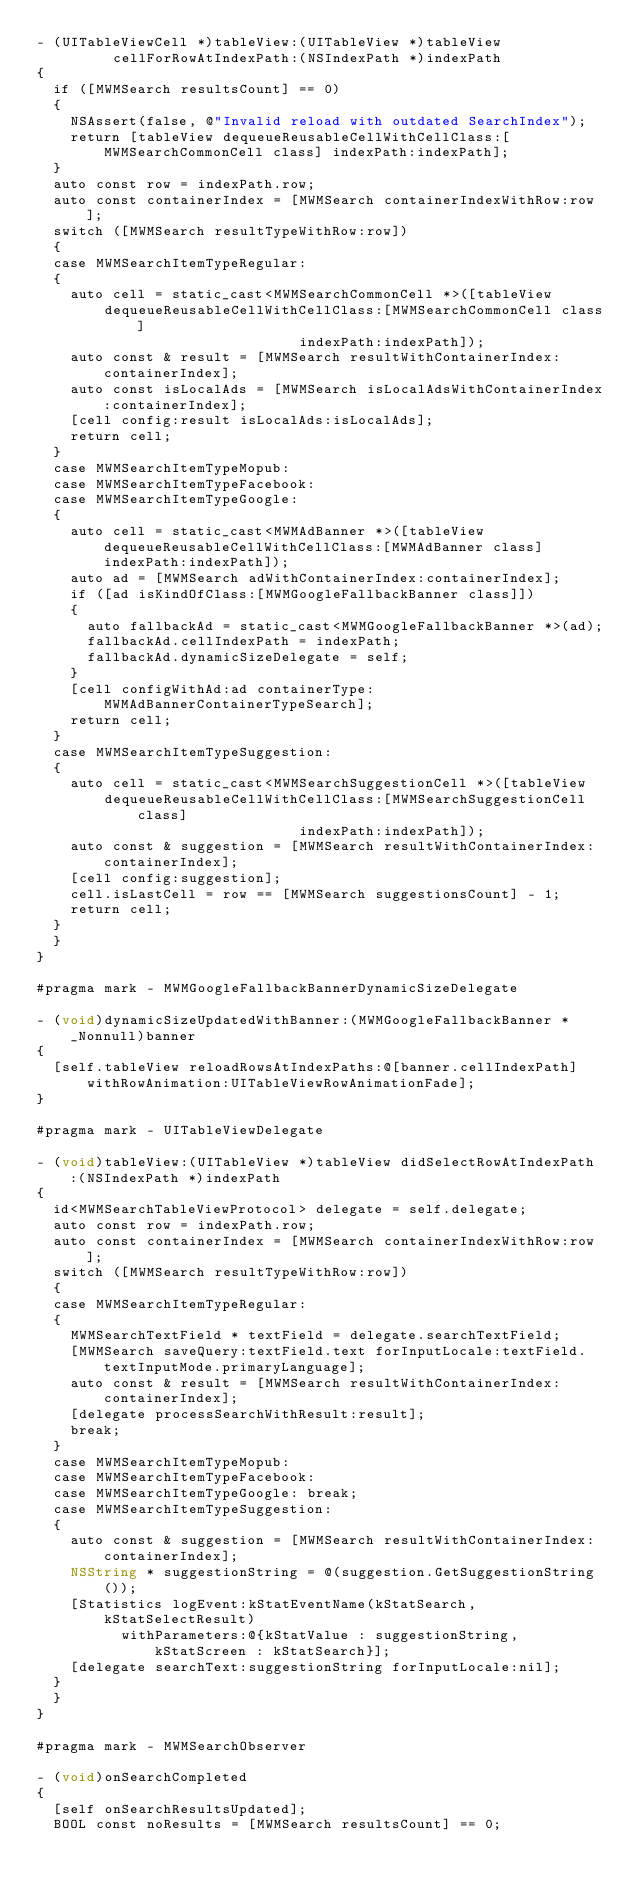<code> <loc_0><loc_0><loc_500><loc_500><_ObjectiveC_>- (UITableViewCell *)tableView:(UITableView *)tableView
         cellForRowAtIndexPath:(NSIndexPath *)indexPath
{
  if ([MWMSearch resultsCount] == 0)
  {
    NSAssert(false, @"Invalid reload with outdated SearchIndex");
    return [tableView dequeueReusableCellWithCellClass:[MWMSearchCommonCell class] indexPath:indexPath];
  }
  auto const row = indexPath.row;
  auto const containerIndex = [MWMSearch containerIndexWithRow:row];
  switch ([MWMSearch resultTypeWithRow:row])
  {
  case MWMSearchItemTypeRegular:
  {
    auto cell = static_cast<MWMSearchCommonCell *>([tableView
        dequeueReusableCellWithCellClass:[MWMSearchCommonCell class]
                               indexPath:indexPath]);
    auto const & result = [MWMSearch resultWithContainerIndex:containerIndex];
    auto const isLocalAds = [MWMSearch isLocalAdsWithContainerIndex:containerIndex];
    [cell config:result isLocalAds:isLocalAds];
    return cell;
  }
  case MWMSearchItemTypeMopub:
  case MWMSearchItemTypeFacebook:
  case MWMSearchItemTypeGoogle:
  {
    auto cell = static_cast<MWMAdBanner *>([tableView dequeueReusableCellWithCellClass:[MWMAdBanner class] indexPath:indexPath]);
    auto ad = [MWMSearch adWithContainerIndex:containerIndex];
    if ([ad isKindOfClass:[MWMGoogleFallbackBanner class]])
    {
      auto fallbackAd = static_cast<MWMGoogleFallbackBanner *>(ad);
      fallbackAd.cellIndexPath = indexPath;
      fallbackAd.dynamicSizeDelegate = self;
    }
    [cell configWithAd:ad containerType:MWMAdBannerContainerTypeSearch];
    return cell;
  }
  case MWMSearchItemTypeSuggestion:
  {
    auto cell = static_cast<MWMSearchSuggestionCell *>([tableView
        dequeueReusableCellWithCellClass:[MWMSearchSuggestionCell class]
                               indexPath:indexPath]);
    auto const & suggestion = [MWMSearch resultWithContainerIndex:containerIndex];
    [cell config:suggestion];
    cell.isLastCell = row == [MWMSearch suggestionsCount] - 1;
    return cell;
  }
  }
}

#pragma mark - MWMGoogleFallbackBannerDynamicSizeDelegate

- (void)dynamicSizeUpdatedWithBanner:(MWMGoogleFallbackBanner * _Nonnull)banner
{
  [self.tableView reloadRowsAtIndexPaths:@[banner.cellIndexPath] withRowAnimation:UITableViewRowAnimationFade];
}

#pragma mark - UITableViewDelegate

- (void)tableView:(UITableView *)tableView didSelectRowAtIndexPath:(NSIndexPath *)indexPath
{
  id<MWMSearchTableViewProtocol> delegate = self.delegate;
  auto const row = indexPath.row;
  auto const containerIndex = [MWMSearch containerIndexWithRow:row];
  switch ([MWMSearch resultTypeWithRow:row])
  {
  case MWMSearchItemTypeRegular:
  {
    MWMSearchTextField * textField = delegate.searchTextField;
    [MWMSearch saveQuery:textField.text forInputLocale:textField.textInputMode.primaryLanguage];
    auto const & result = [MWMSearch resultWithContainerIndex:containerIndex];
    [delegate processSearchWithResult:result];
    break;
  }
  case MWMSearchItemTypeMopub: 
  case MWMSearchItemTypeFacebook:
  case MWMSearchItemTypeGoogle: break;
  case MWMSearchItemTypeSuggestion:
  {
    auto const & suggestion = [MWMSearch resultWithContainerIndex:containerIndex];
    NSString * suggestionString = @(suggestion.GetSuggestionString());
    [Statistics logEvent:kStatEventName(kStatSearch, kStatSelectResult)
          withParameters:@{kStatValue : suggestionString, kStatScreen : kStatSearch}];
    [delegate searchText:suggestionString forInputLocale:nil];
  }
  }
}

#pragma mark - MWMSearchObserver

- (void)onSearchCompleted
{
  [self onSearchResultsUpdated];
  BOOL const noResults = [MWMSearch resultsCount] == 0;</code> 